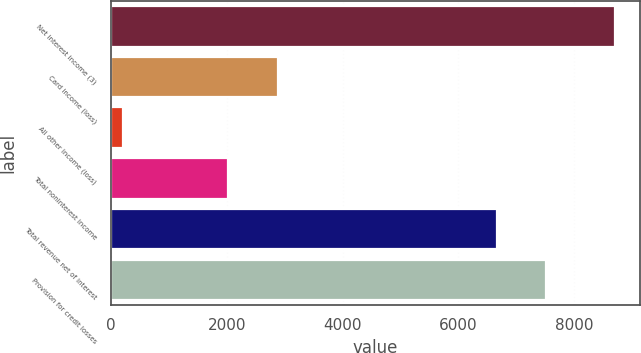<chart> <loc_0><loc_0><loc_500><loc_500><bar_chart><fcel>Net interest income (3)<fcel>Card income (loss)<fcel>All other income (loss)<fcel>Total noninterest income<fcel>Total revenue net of interest<fcel>Provision for credit losses<nl><fcel>8701<fcel>2879.2<fcel>219<fcel>2031<fcel>6670<fcel>7518.2<nl></chart> 